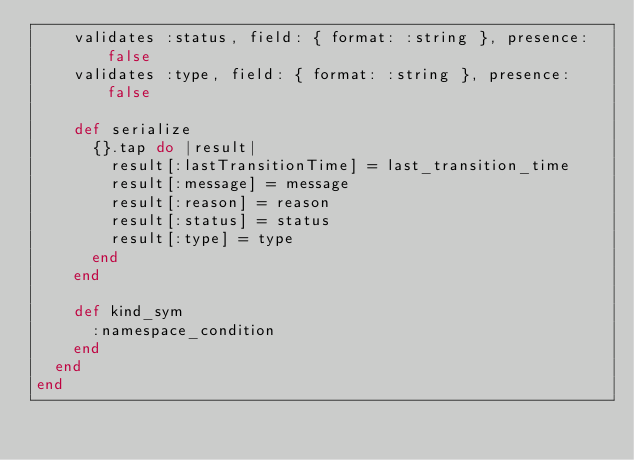Convert code to text. <code><loc_0><loc_0><loc_500><loc_500><_Ruby_>    validates :status, field: { format: :string }, presence: false
    validates :type, field: { format: :string }, presence: false

    def serialize
      {}.tap do |result|
        result[:lastTransitionTime] = last_transition_time
        result[:message] = message
        result[:reason] = reason
        result[:status] = status
        result[:type] = type
      end
    end

    def kind_sym
      :namespace_condition
    end
  end
end
</code> 